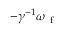Convert formula to latex. <formula><loc_0><loc_0><loc_500><loc_500>- \gamma ^ { - 1 } \omega _ { f }</formula> 